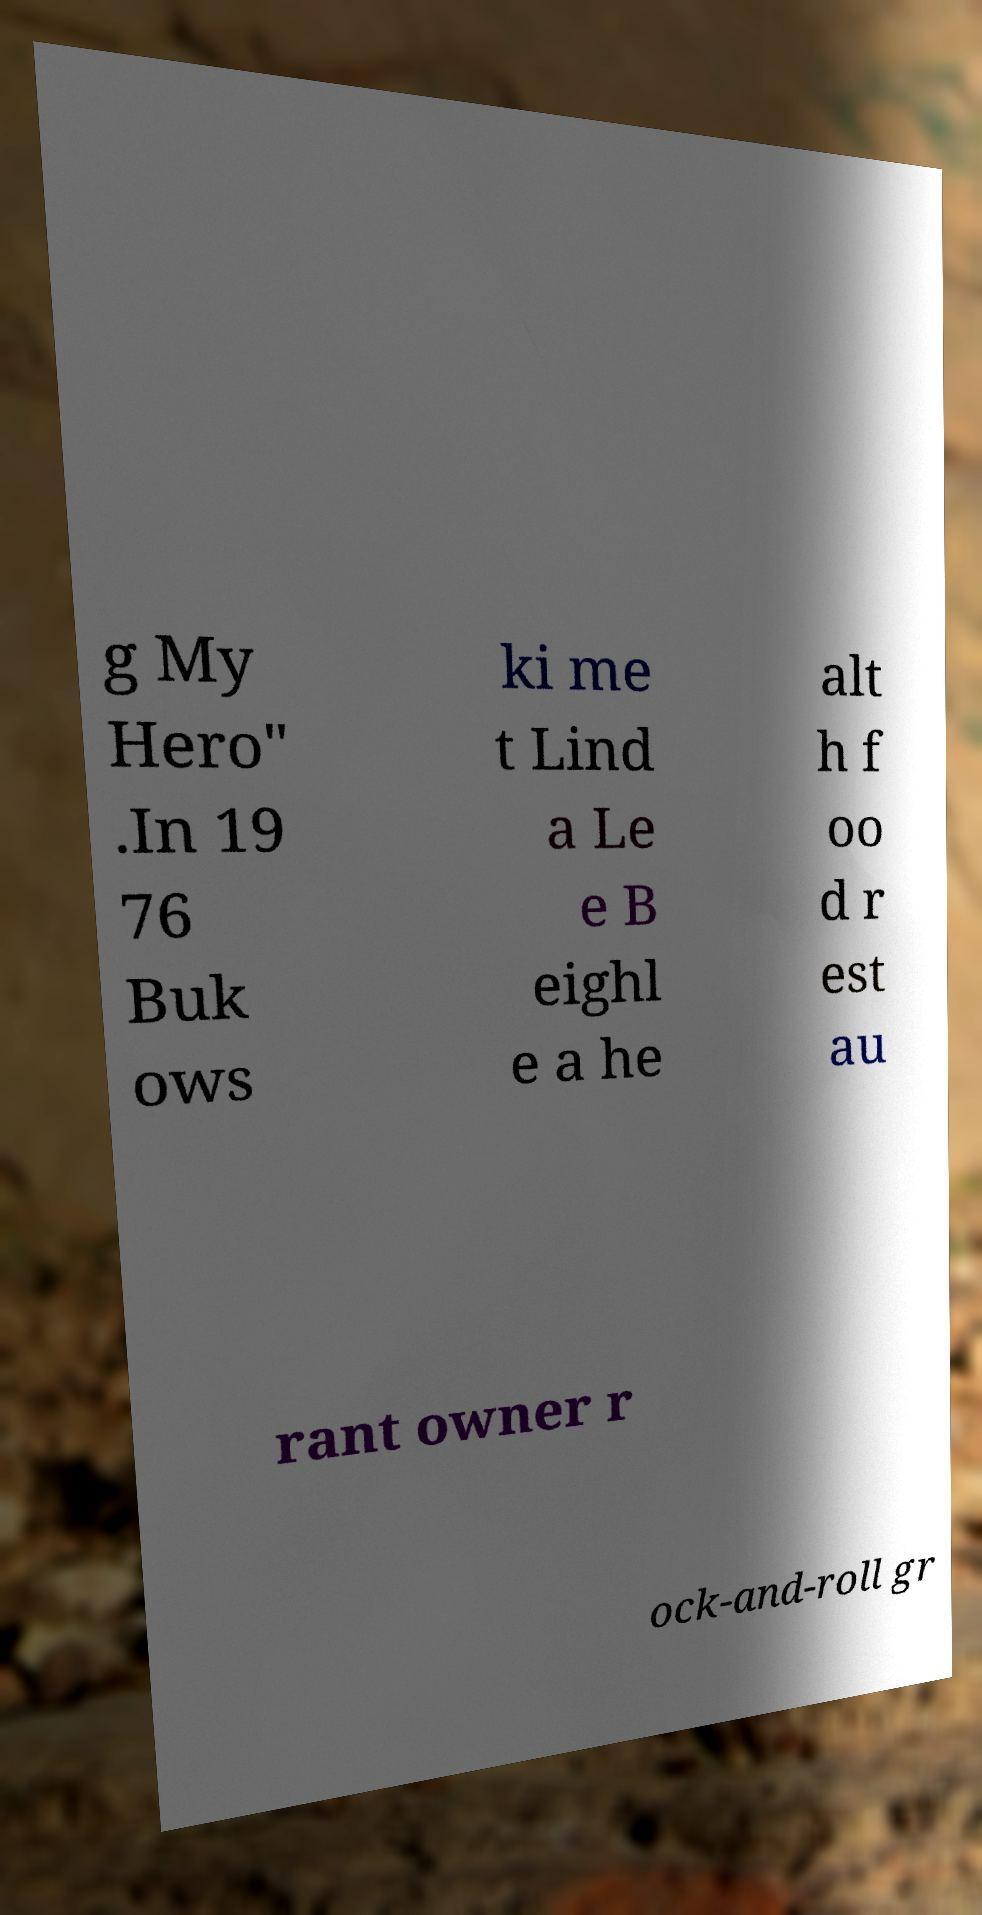I need the written content from this picture converted into text. Can you do that? g My Hero" .In 19 76 Buk ows ki me t Lind a Le e B eighl e a he alt h f oo d r est au rant owner r ock-and-roll gr 